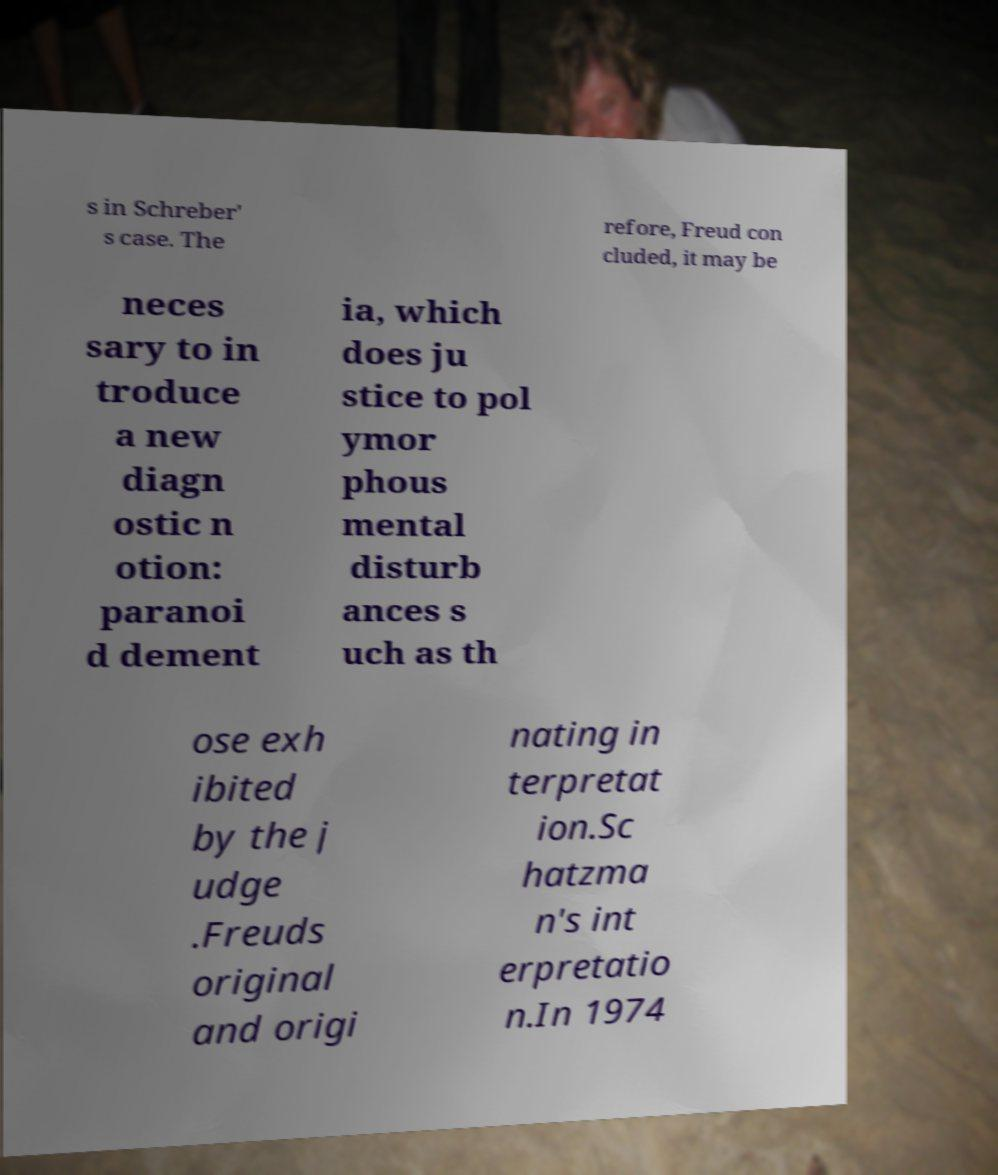Could you extract and type out the text from this image? s in Schreber' s case. The refore, Freud con cluded, it may be neces sary to in troduce a new diagn ostic n otion: paranoi d dement ia, which does ju stice to pol ymor phous mental disturb ances s uch as th ose exh ibited by the j udge .Freuds original and origi nating in terpretat ion.Sc hatzma n's int erpretatio n.In 1974 